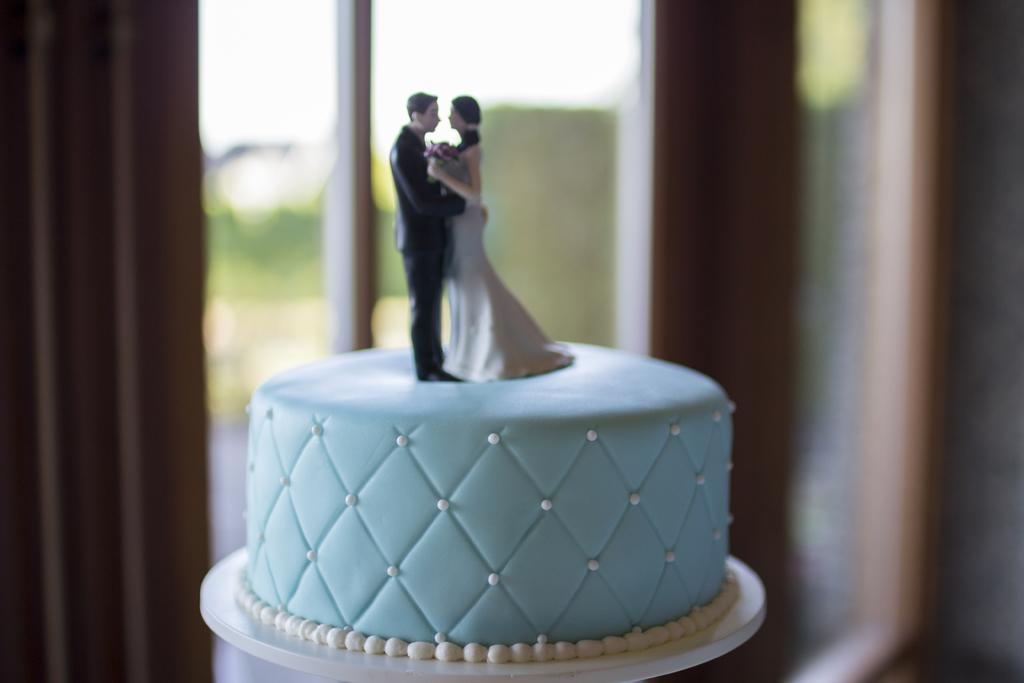What is the main subject of the image? There is a cake in the image. What decorations are on the cake? The cake has idols of a man and a woman on it. What can be seen in the background of the image? There is a window in the background of the image. Is there any window treatment present in the image? Yes, there is a curtain associated with the window. How many boys are standing near the lake in the image? There is no lake or boys present in the image; it features a cake with idols and a window with a curtain. 